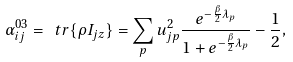Convert formula to latex. <formula><loc_0><loc_0><loc_500><loc_500>\alpha _ { i j } ^ { 0 3 } = \ t r { \{ \rho I _ { j z } \} } = \sum _ { p } u _ { j p } ^ { 2 } \frac { e ^ { - \frac { \beta } 2 \lambda _ { p } } } { 1 + e ^ { - \frac { \beta } 2 \lambda _ { p } } } - \frac { 1 } { 2 } ,</formula> 